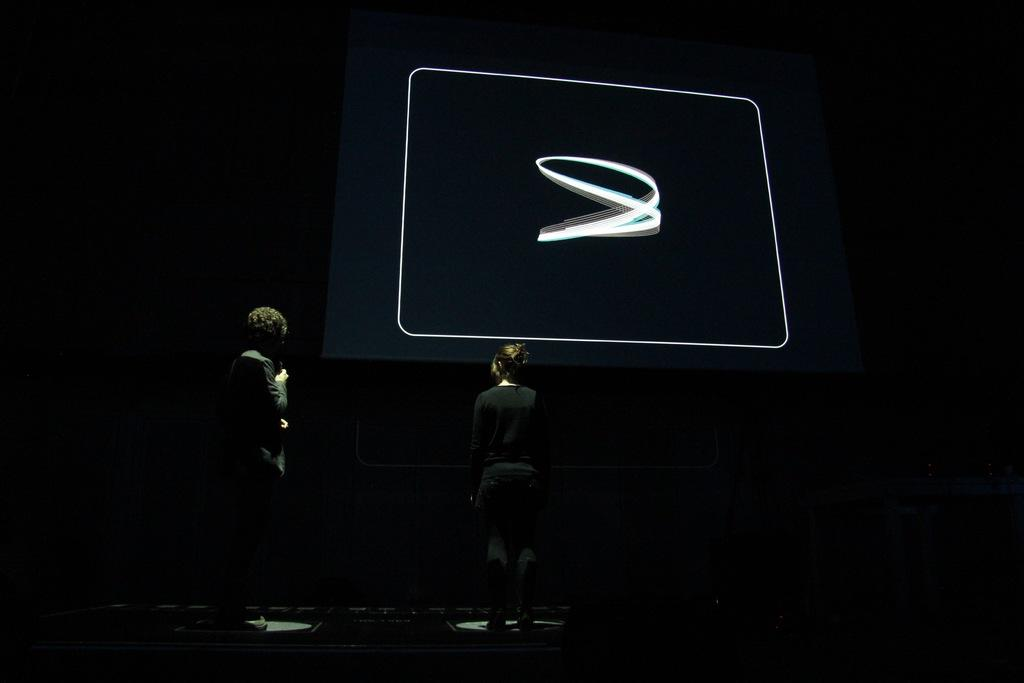How many people are in the image? There are two persons in the image. What is one of the persons holding? One of the persons is holding a mic. What can be seen in front of the two persons? There is a screen in front of the two persons. How much money is being exchanged between the two persons in the image? There is no indication of money being exchanged between the two persons in the image. What type of power source is being used to operate the screen in the image? The image does not provide information about the power source for the screen. 